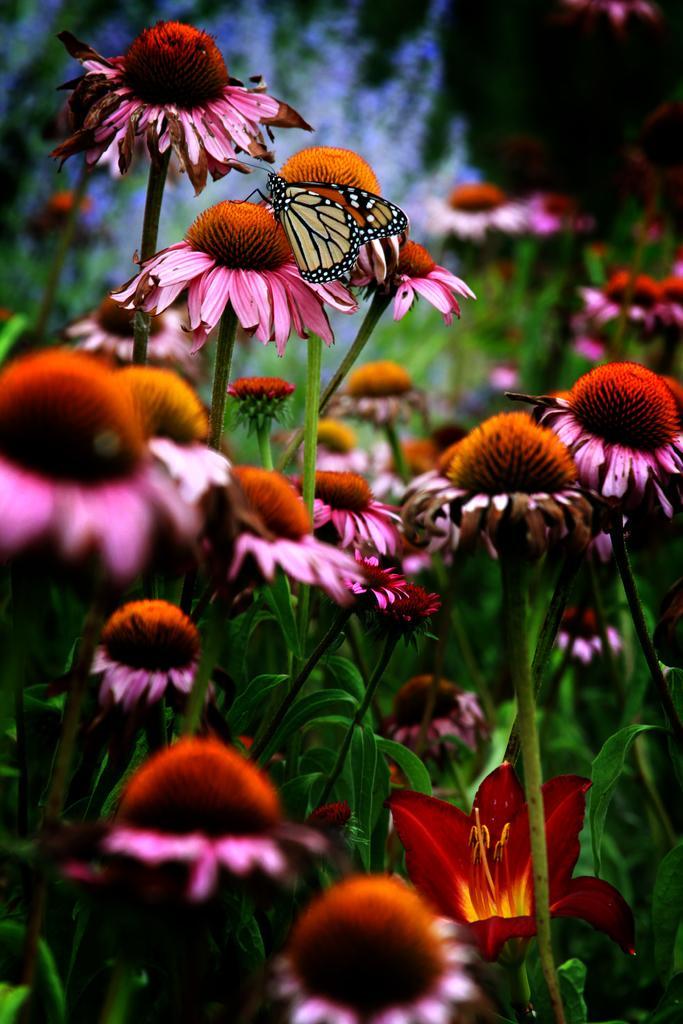Can you describe this image briefly? In this image we can see flowers to the plants and a butterfly on one of the flowers. 